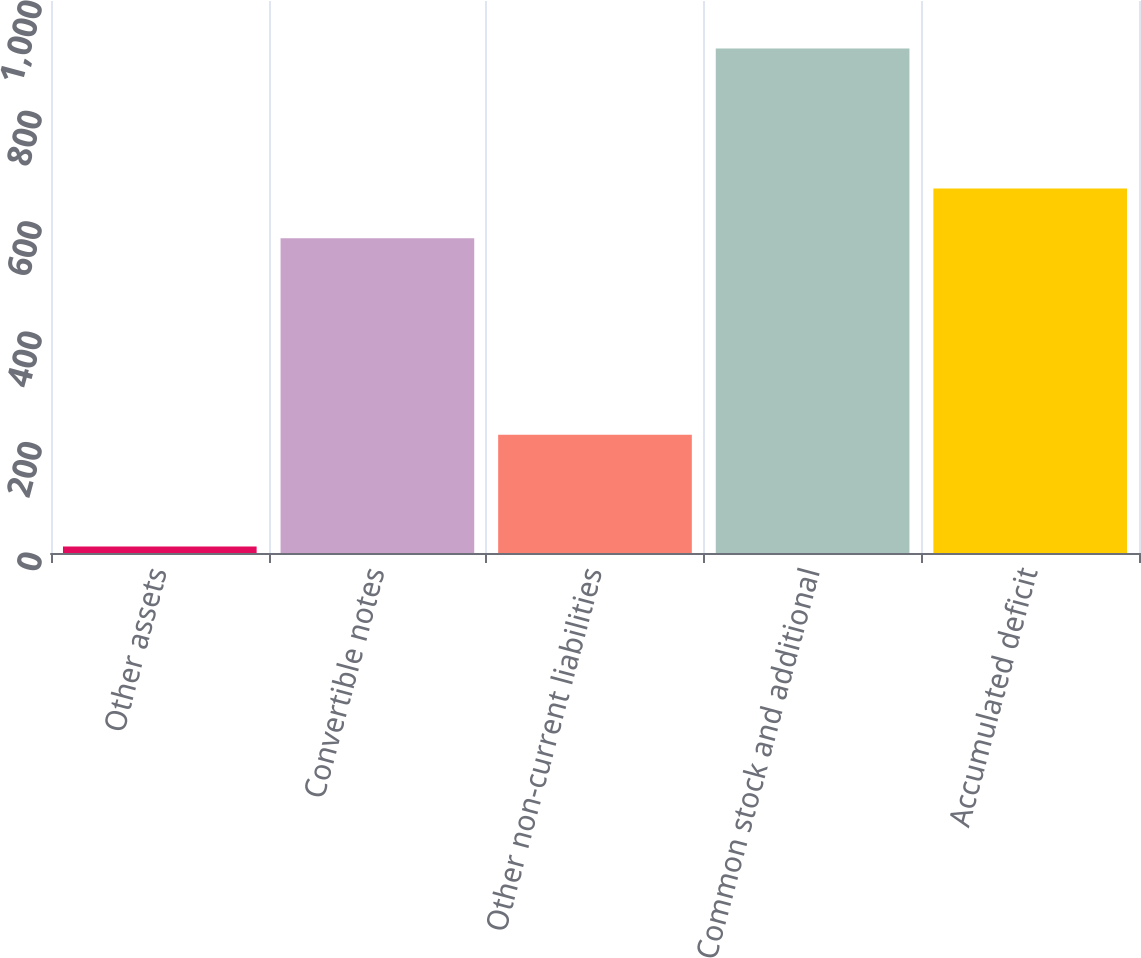Convert chart to OTSL. <chart><loc_0><loc_0><loc_500><loc_500><bar_chart><fcel>Other assets<fcel>Convertible notes<fcel>Other non-current liabilities<fcel>Common stock and additional<fcel>Accumulated deficit<nl><fcel>12<fcel>570<fcel>214<fcel>914<fcel>660.2<nl></chart> 